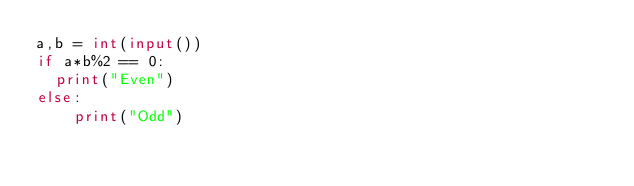<code> <loc_0><loc_0><loc_500><loc_500><_Python_>a,b = int(input())
if a*b%2 == 0:
	print("Even")
else:
  	print("Odd")
  </code> 